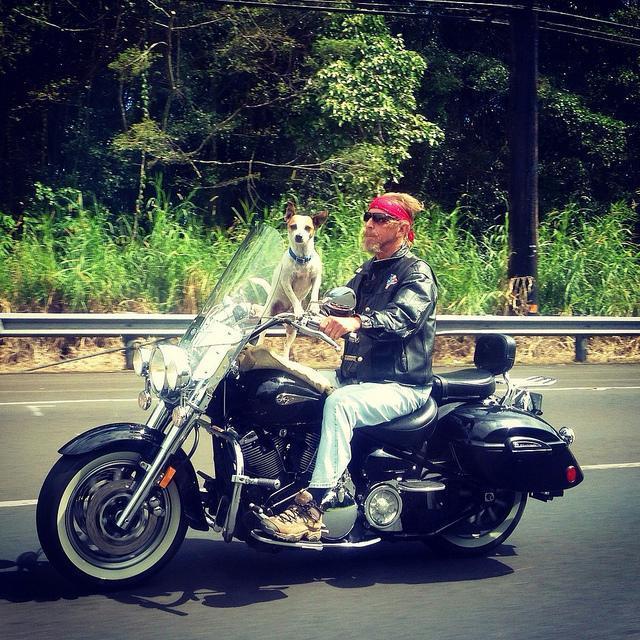How many train cars are painted black?
Give a very brief answer. 0. 